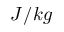<formula> <loc_0><loc_0><loc_500><loc_500>J / k g</formula> 